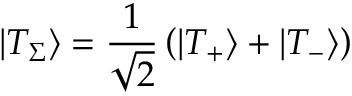<formula> <loc_0><loc_0><loc_500><loc_500>\left | { { T _ { \Sigma } } } \right \rangle = \frac { 1 } { \sqrt { 2 } } \left ( { \left | { { T _ { + } } } \right \rangle + \left | { { T _ { - } } } \right \rangle } \right )</formula> 